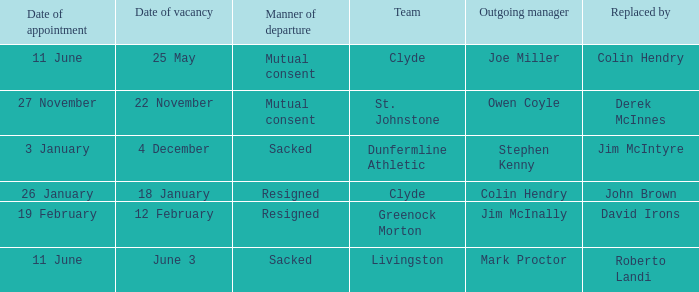Tell me the outgoing manager for 22 november date of vacancy Owen Coyle. 